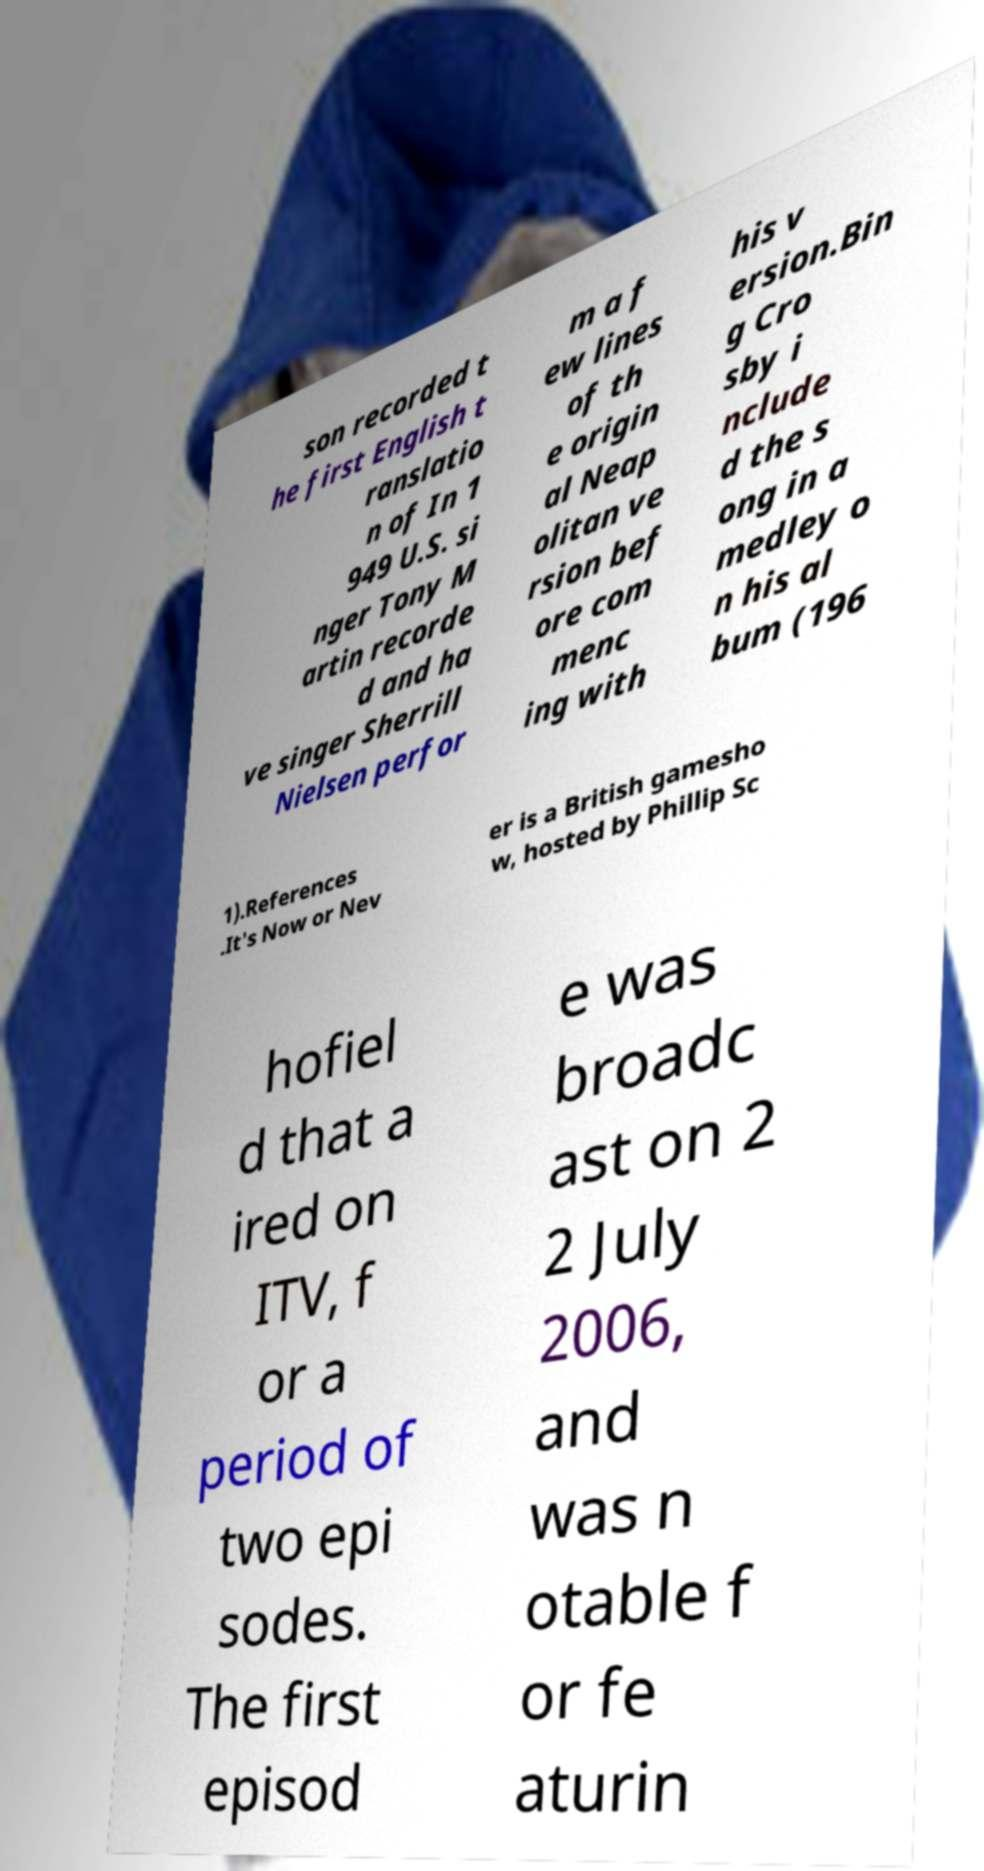Please identify and transcribe the text found in this image. son recorded t he first English t ranslatio n of In 1 949 U.S. si nger Tony M artin recorde d and ha ve singer Sherrill Nielsen perfor m a f ew lines of th e origin al Neap olitan ve rsion bef ore com menc ing with his v ersion.Bin g Cro sby i nclude d the s ong in a medley o n his al bum (196 1).References .It's Now or Nev er is a British gamesho w, hosted by Phillip Sc hofiel d that a ired on ITV, f or a period of two epi sodes. The first episod e was broadc ast on 2 2 July 2006, and was n otable f or fe aturin 